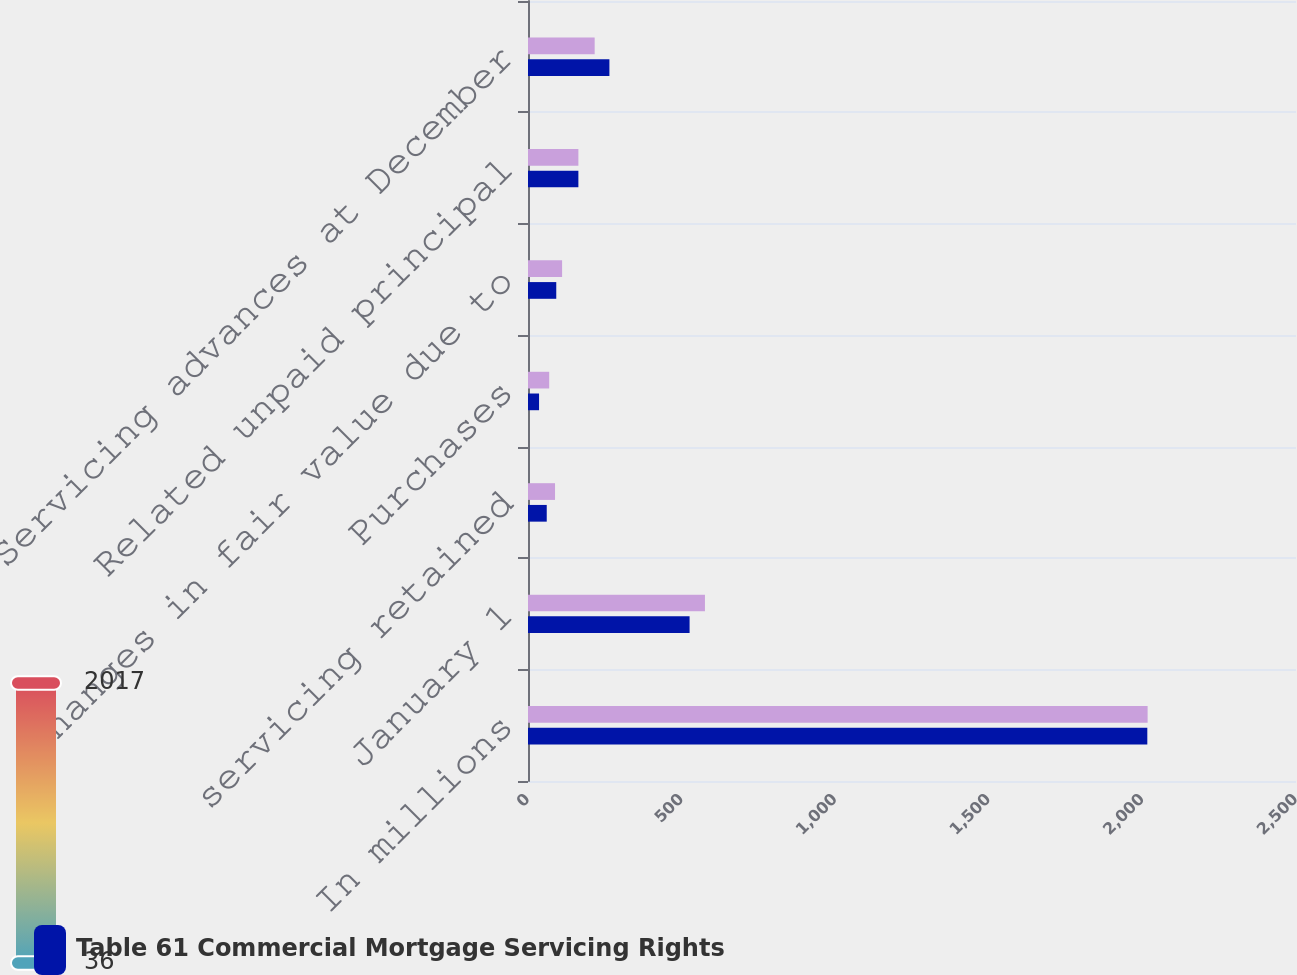Convert chart. <chart><loc_0><loc_0><loc_500><loc_500><stacked_bar_chart><ecel><fcel>In millions<fcel>January 1<fcel>servicing retained<fcel>Purchases<fcel>Changes in fair value due to<fcel>Related unpaid principal<fcel>Servicing advances at December<nl><fcel>nan<fcel>2017<fcel>576<fcel>88<fcel>69<fcel>111<fcel>164<fcel>217<nl><fcel>Table 61 Commercial Mortgage Servicing Rights<fcel>2016<fcel>526<fcel>61<fcel>36<fcel>92<fcel>164<fcel>265<nl></chart> 